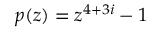<formula> <loc_0><loc_0><loc_500><loc_500>p ( z ) = z ^ { 4 + 3 i } - 1</formula> 